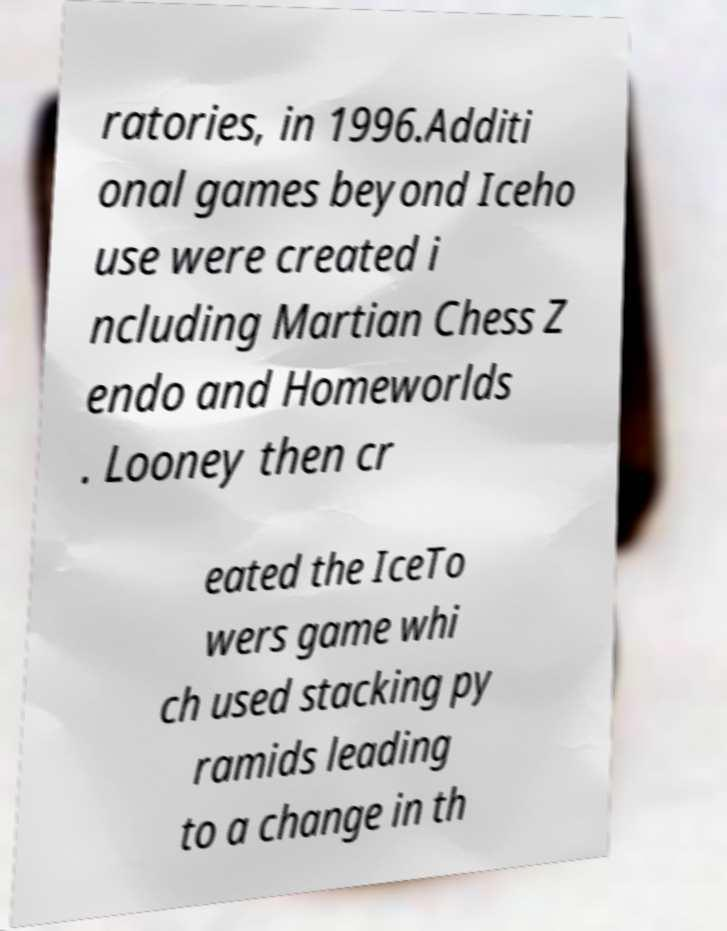For documentation purposes, I need the text within this image transcribed. Could you provide that? ratories, in 1996.Additi onal games beyond Iceho use were created i ncluding Martian Chess Z endo and Homeworlds . Looney then cr eated the IceTo wers game whi ch used stacking py ramids leading to a change in th 